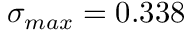Convert formula to latex. <formula><loc_0><loc_0><loc_500><loc_500>\sigma _ { \max } = 0 . 3 3 8</formula> 